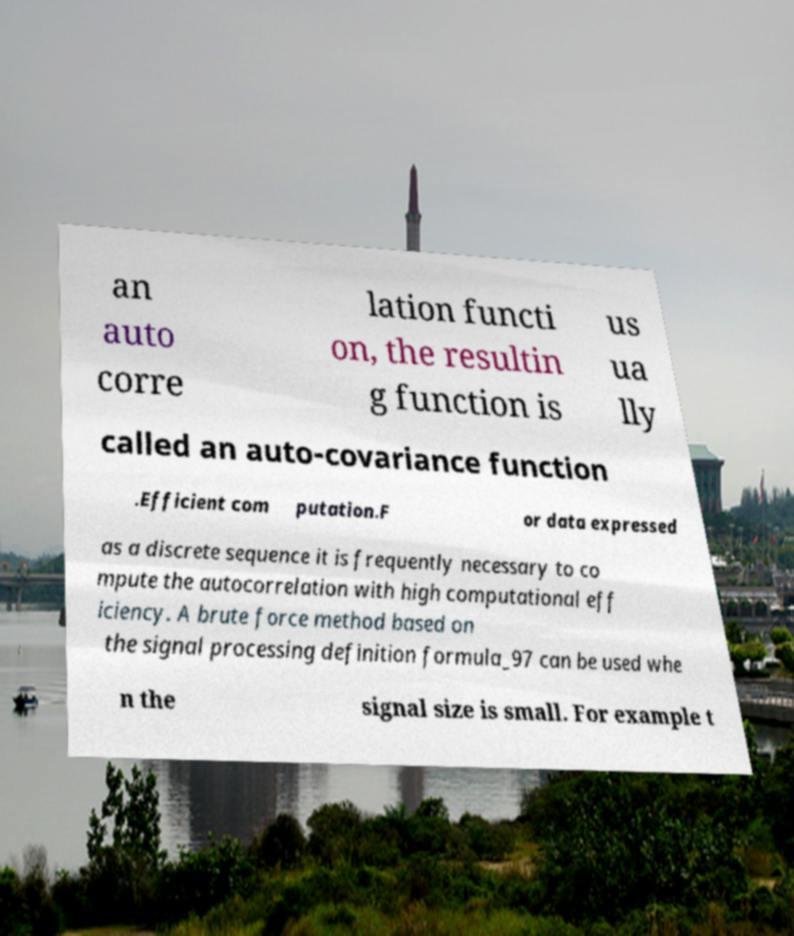There's text embedded in this image that I need extracted. Can you transcribe it verbatim? an auto corre lation functi on, the resultin g function is us ua lly called an auto-covariance function .Efficient com putation.F or data expressed as a discrete sequence it is frequently necessary to co mpute the autocorrelation with high computational eff iciency. A brute force method based on the signal processing definition formula_97 can be used whe n the signal size is small. For example t 